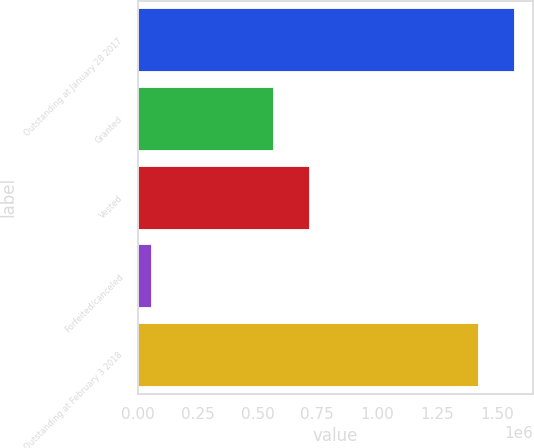Convert chart to OTSL. <chart><loc_0><loc_0><loc_500><loc_500><bar_chart><fcel>Outstanding at January 28 2017<fcel>Granted<fcel>Vested<fcel>Forfeited/canceled<fcel>Outstanding at February 3 2018<nl><fcel>1.5718e+06<fcel>564000<fcel>713800<fcel>54000<fcel>1.422e+06<nl></chart> 